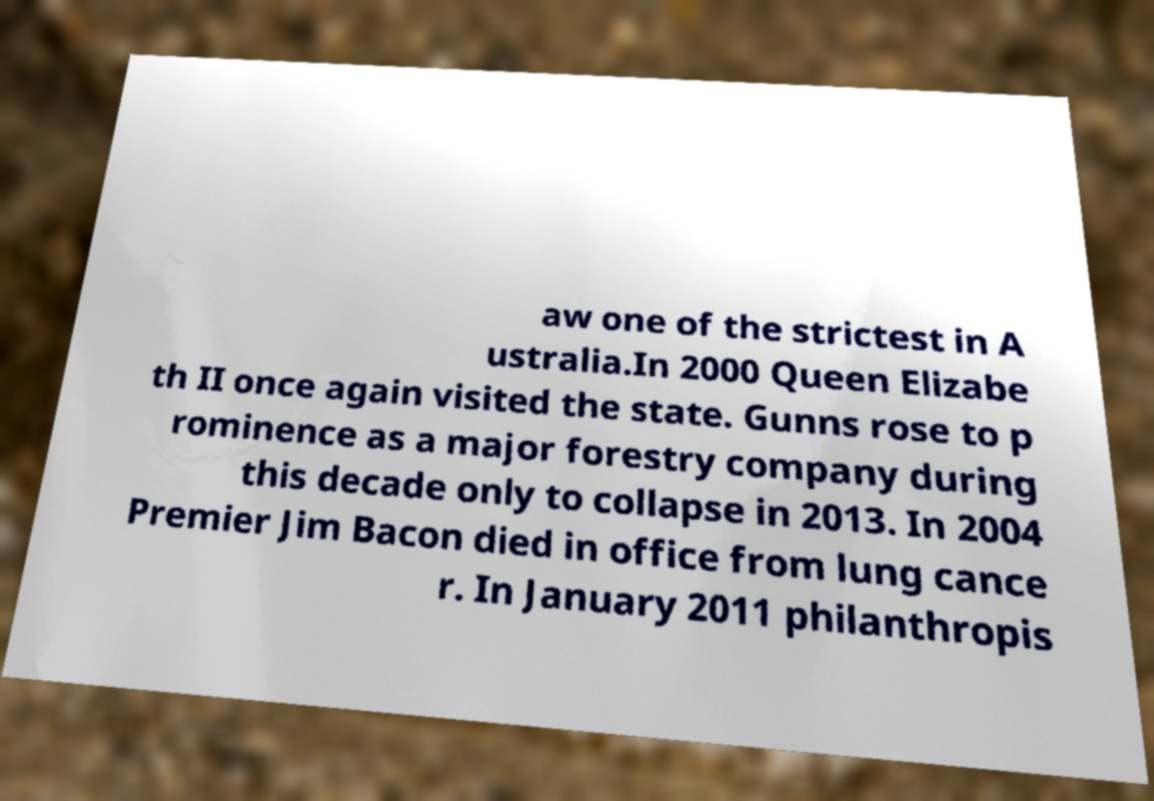For documentation purposes, I need the text within this image transcribed. Could you provide that? aw one of the strictest in A ustralia.In 2000 Queen Elizabe th II once again visited the state. Gunns rose to p rominence as a major forestry company during this decade only to collapse in 2013. In 2004 Premier Jim Bacon died in office from lung cance r. In January 2011 philanthropis 